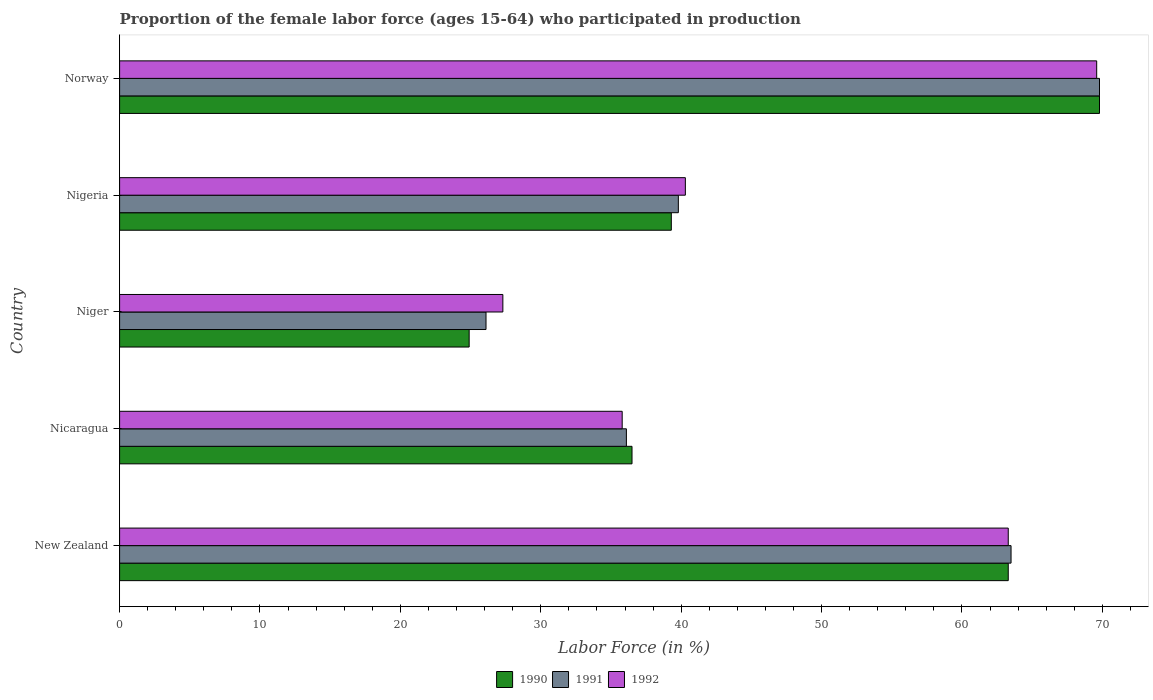How many different coloured bars are there?
Offer a terse response. 3. Are the number of bars per tick equal to the number of legend labels?
Your answer should be compact. Yes. Are the number of bars on each tick of the Y-axis equal?
Your response must be concise. Yes. What is the label of the 5th group of bars from the top?
Keep it short and to the point. New Zealand. In how many cases, is the number of bars for a given country not equal to the number of legend labels?
Your response must be concise. 0. What is the proportion of the female labor force who participated in production in 1992 in New Zealand?
Your answer should be compact. 63.3. Across all countries, what is the maximum proportion of the female labor force who participated in production in 1991?
Give a very brief answer. 69.8. Across all countries, what is the minimum proportion of the female labor force who participated in production in 1992?
Give a very brief answer. 27.3. In which country was the proportion of the female labor force who participated in production in 1990 maximum?
Your answer should be very brief. Norway. In which country was the proportion of the female labor force who participated in production in 1991 minimum?
Offer a terse response. Niger. What is the total proportion of the female labor force who participated in production in 1990 in the graph?
Offer a very short reply. 233.8. What is the difference between the proportion of the female labor force who participated in production in 1990 in New Zealand and that in Niger?
Your answer should be very brief. 38.4. What is the difference between the proportion of the female labor force who participated in production in 1991 in New Zealand and the proportion of the female labor force who participated in production in 1992 in Niger?
Offer a terse response. 36.2. What is the average proportion of the female labor force who participated in production in 1992 per country?
Your answer should be very brief. 47.26. What is the difference between the proportion of the female labor force who participated in production in 1991 and proportion of the female labor force who participated in production in 1992 in New Zealand?
Your answer should be compact. 0.2. What is the ratio of the proportion of the female labor force who participated in production in 1991 in New Zealand to that in Nigeria?
Provide a succinct answer. 1.6. Is the proportion of the female labor force who participated in production in 1991 in Nigeria less than that in Norway?
Make the answer very short. Yes. Is the difference between the proportion of the female labor force who participated in production in 1991 in Nicaragua and Nigeria greater than the difference between the proportion of the female labor force who participated in production in 1992 in Nicaragua and Nigeria?
Make the answer very short. Yes. What is the difference between the highest and the second highest proportion of the female labor force who participated in production in 1992?
Ensure brevity in your answer.  6.3. What is the difference between the highest and the lowest proportion of the female labor force who participated in production in 1992?
Your response must be concise. 42.3. Is the sum of the proportion of the female labor force who participated in production in 1991 in Nigeria and Norway greater than the maximum proportion of the female labor force who participated in production in 1990 across all countries?
Your answer should be very brief. Yes. How many bars are there?
Offer a very short reply. 15. Are the values on the major ticks of X-axis written in scientific E-notation?
Provide a succinct answer. No. Does the graph contain grids?
Offer a very short reply. No. What is the title of the graph?
Keep it short and to the point. Proportion of the female labor force (ages 15-64) who participated in production. What is the label or title of the Y-axis?
Ensure brevity in your answer.  Country. What is the Labor Force (in %) in 1990 in New Zealand?
Your answer should be very brief. 63.3. What is the Labor Force (in %) of 1991 in New Zealand?
Offer a very short reply. 63.5. What is the Labor Force (in %) of 1992 in New Zealand?
Keep it short and to the point. 63.3. What is the Labor Force (in %) of 1990 in Nicaragua?
Your response must be concise. 36.5. What is the Labor Force (in %) in 1991 in Nicaragua?
Make the answer very short. 36.1. What is the Labor Force (in %) of 1992 in Nicaragua?
Give a very brief answer. 35.8. What is the Labor Force (in %) of 1990 in Niger?
Ensure brevity in your answer.  24.9. What is the Labor Force (in %) of 1991 in Niger?
Keep it short and to the point. 26.1. What is the Labor Force (in %) in 1992 in Niger?
Your answer should be compact. 27.3. What is the Labor Force (in %) in 1990 in Nigeria?
Offer a terse response. 39.3. What is the Labor Force (in %) in 1991 in Nigeria?
Keep it short and to the point. 39.8. What is the Labor Force (in %) of 1992 in Nigeria?
Ensure brevity in your answer.  40.3. What is the Labor Force (in %) in 1990 in Norway?
Your answer should be very brief. 69.8. What is the Labor Force (in %) of 1991 in Norway?
Give a very brief answer. 69.8. What is the Labor Force (in %) of 1992 in Norway?
Keep it short and to the point. 69.6. Across all countries, what is the maximum Labor Force (in %) in 1990?
Your answer should be compact. 69.8. Across all countries, what is the maximum Labor Force (in %) in 1991?
Provide a succinct answer. 69.8. Across all countries, what is the maximum Labor Force (in %) of 1992?
Keep it short and to the point. 69.6. Across all countries, what is the minimum Labor Force (in %) of 1990?
Your response must be concise. 24.9. Across all countries, what is the minimum Labor Force (in %) of 1991?
Provide a succinct answer. 26.1. Across all countries, what is the minimum Labor Force (in %) of 1992?
Provide a short and direct response. 27.3. What is the total Labor Force (in %) in 1990 in the graph?
Your answer should be compact. 233.8. What is the total Labor Force (in %) in 1991 in the graph?
Your answer should be compact. 235.3. What is the total Labor Force (in %) of 1992 in the graph?
Provide a succinct answer. 236.3. What is the difference between the Labor Force (in %) in 1990 in New Zealand and that in Nicaragua?
Keep it short and to the point. 26.8. What is the difference between the Labor Force (in %) of 1991 in New Zealand and that in Nicaragua?
Offer a very short reply. 27.4. What is the difference between the Labor Force (in %) in 1990 in New Zealand and that in Niger?
Your answer should be compact. 38.4. What is the difference between the Labor Force (in %) of 1991 in New Zealand and that in Niger?
Offer a very short reply. 37.4. What is the difference between the Labor Force (in %) in 1992 in New Zealand and that in Niger?
Provide a succinct answer. 36. What is the difference between the Labor Force (in %) in 1990 in New Zealand and that in Nigeria?
Ensure brevity in your answer.  24. What is the difference between the Labor Force (in %) in 1991 in New Zealand and that in Nigeria?
Offer a terse response. 23.7. What is the difference between the Labor Force (in %) of 1992 in New Zealand and that in Nigeria?
Offer a terse response. 23. What is the difference between the Labor Force (in %) in 1990 in New Zealand and that in Norway?
Provide a succinct answer. -6.5. What is the difference between the Labor Force (in %) of 1992 in New Zealand and that in Norway?
Ensure brevity in your answer.  -6.3. What is the difference between the Labor Force (in %) in 1990 in Nicaragua and that in Niger?
Provide a short and direct response. 11.6. What is the difference between the Labor Force (in %) in 1992 in Nicaragua and that in Niger?
Provide a short and direct response. 8.5. What is the difference between the Labor Force (in %) in 1990 in Nicaragua and that in Nigeria?
Keep it short and to the point. -2.8. What is the difference between the Labor Force (in %) in 1990 in Nicaragua and that in Norway?
Make the answer very short. -33.3. What is the difference between the Labor Force (in %) in 1991 in Nicaragua and that in Norway?
Give a very brief answer. -33.7. What is the difference between the Labor Force (in %) of 1992 in Nicaragua and that in Norway?
Ensure brevity in your answer.  -33.8. What is the difference between the Labor Force (in %) of 1990 in Niger and that in Nigeria?
Give a very brief answer. -14.4. What is the difference between the Labor Force (in %) of 1991 in Niger and that in Nigeria?
Your answer should be compact. -13.7. What is the difference between the Labor Force (in %) of 1992 in Niger and that in Nigeria?
Your answer should be compact. -13. What is the difference between the Labor Force (in %) of 1990 in Niger and that in Norway?
Ensure brevity in your answer.  -44.9. What is the difference between the Labor Force (in %) of 1991 in Niger and that in Norway?
Give a very brief answer. -43.7. What is the difference between the Labor Force (in %) in 1992 in Niger and that in Norway?
Your response must be concise. -42.3. What is the difference between the Labor Force (in %) of 1990 in Nigeria and that in Norway?
Keep it short and to the point. -30.5. What is the difference between the Labor Force (in %) of 1991 in Nigeria and that in Norway?
Provide a succinct answer. -30. What is the difference between the Labor Force (in %) of 1992 in Nigeria and that in Norway?
Your answer should be very brief. -29.3. What is the difference between the Labor Force (in %) of 1990 in New Zealand and the Labor Force (in %) of 1991 in Nicaragua?
Provide a succinct answer. 27.2. What is the difference between the Labor Force (in %) of 1990 in New Zealand and the Labor Force (in %) of 1992 in Nicaragua?
Make the answer very short. 27.5. What is the difference between the Labor Force (in %) of 1991 in New Zealand and the Labor Force (in %) of 1992 in Nicaragua?
Your answer should be very brief. 27.7. What is the difference between the Labor Force (in %) of 1990 in New Zealand and the Labor Force (in %) of 1991 in Niger?
Your response must be concise. 37.2. What is the difference between the Labor Force (in %) in 1991 in New Zealand and the Labor Force (in %) in 1992 in Niger?
Offer a very short reply. 36.2. What is the difference between the Labor Force (in %) in 1990 in New Zealand and the Labor Force (in %) in 1991 in Nigeria?
Offer a terse response. 23.5. What is the difference between the Labor Force (in %) in 1991 in New Zealand and the Labor Force (in %) in 1992 in Nigeria?
Provide a succinct answer. 23.2. What is the difference between the Labor Force (in %) of 1990 in New Zealand and the Labor Force (in %) of 1992 in Norway?
Make the answer very short. -6.3. What is the difference between the Labor Force (in %) of 1990 in Nicaragua and the Labor Force (in %) of 1992 in Niger?
Keep it short and to the point. 9.2. What is the difference between the Labor Force (in %) in 1990 in Nicaragua and the Labor Force (in %) in 1991 in Nigeria?
Your response must be concise. -3.3. What is the difference between the Labor Force (in %) in 1990 in Nicaragua and the Labor Force (in %) in 1992 in Nigeria?
Keep it short and to the point. -3.8. What is the difference between the Labor Force (in %) of 1991 in Nicaragua and the Labor Force (in %) of 1992 in Nigeria?
Give a very brief answer. -4.2. What is the difference between the Labor Force (in %) in 1990 in Nicaragua and the Labor Force (in %) in 1991 in Norway?
Keep it short and to the point. -33.3. What is the difference between the Labor Force (in %) of 1990 in Nicaragua and the Labor Force (in %) of 1992 in Norway?
Offer a terse response. -33.1. What is the difference between the Labor Force (in %) of 1991 in Nicaragua and the Labor Force (in %) of 1992 in Norway?
Your answer should be very brief. -33.5. What is the difference between the Labor Force (in %) in 1990 in Niger and the Labor Force (in %) in 1991 in Nigeria?
Give a very brief answer. -14.9. What is the difference between the Labor Force (in %) in 1990 in Niger and the Labor Force (in %) in 1992 in Nigeria?
Offer a terse response. -15.4. What is the difference between the Labor Force (in %) in 1991 in Niger and the Labor Force (in %) in 1992 in Nigeria?
Make the answer very short. -14.2. What is the difference between the Labor Force (in %) of 1990 in Niger and the Labor Force (in %) of 1991 in Norway?
Keep it short and to the point. -44.9. What is the difference between the Labor Force (in %) of 1990 in Niger and the Labor Force (in %) of 1992 in Norway?
Provide a succinct answer. -44.7. What is the difference between the Labor Force (in %) of 1991 in Niger and the Labor Force (in %) of 1992 in Norway?
Offer a terse response. -43.5. What is the difference between the Labor Force (in %) of 1990 in Nigeria and the Labor Force (in %) of 1991 in Norway?
Keep it short and to the point. -30.5. What is the difference between the Labor Force (in %) of 1990 in Nigeria and the Labor Force (in %) of 1992 in Norway?
Your answer should be very brief. -30.3. What is the difference between the Labor Force (in %) of 1991 in Nigeria and the Labor Force (in %) of 1992 in Norway?
Offer a very short reply. -29.8. What is the average Labor Force (in %) in 1990 per country?
Your answer should be very brief. 46.76. What is the average Labor Force (in %) of 1991 per country?
Your answer should be compact. 47.06. What is the average Labor Force (in %) of 1992 per country?
Your answer should be compact. 47.26. What is the difference between the Labor Force (in %) of 1990 and Labor Force (in %) of 1991 in New Zealand?
Ensure brevity in your answer.  -0.2. What is the difference between the Labor Force (in %) of 1990 and Labor Force (in %) of 1992 in New Zealand?
Your answer should be very brief. 0. What is the difference between the Labor Force (in %) in 1991 and Labor Force (in %) in 1992 in New Zealand?
Your answer should be compact. 0.2. What is the difference between the Labor Force (in %) of 1990 and Labor Force (in %) of 1991 in Nicaragua?
Ensure brevity in your answer.  0.4. What is the difference between the Labor Force (in %) in 1990 and Labor Force (in %) in 1992 in Nicaragua?
Provide a short and direct response. 0.7. What is the difference between the Labor Force (in %) of 1990 and Labor Force (in %) of 1991 in Niger?
Your answer should be compact. -1.2. What is the difference between the Labor Force (in %) in 1990 and Labor Force (in %) in 1991 in Nigeria?
Your answer should be compact. -0.5. What is the difference between the Labor Force (in %) in 1990 and Labor Force (in %) in 1992 in Nigeria?
Keep it short and to the point. -1. What is the difference between the Labor Force (in %) of 1991 and Labor Force (in %) of 1992 in Nigeria?
Provide a succinct answer. -0.5. What is the difference between the Labor Force (in %) of 1990 and Labor Force (in %) of 1992 in Norway?
Ensure brevity in your answer.  0.2. What is the difference between the Labor Force (in %) in 1991 and Labor Force (in %) in 1992 in Norway?
Keep it short and to the point. 0.2. What is the ratio of the Labor Force (in %) of 1990 in New Zealand to that in Nicaragua?
Give a very brief answer. 1.73. What is the ratio of the Labor Force (in %) of 1991 in New Zealand to that in Nicaragua?
Offer a very short reply. 1.76. What is the ratio of the Labor Force (in %) in 1992 in New Zealand to that in Nicaragua?
Keep it short and to the point. 1.77. What is the ratio of the Labor Force (in %) in 1990 in New Zealand to that in Niger?
Provide a succinct answer. 2.54. What is the ratio of the Labor Force (in %) in 1991 in New Zealand to that in Niger?
Your answer should be compact. 2.43. What is the ratio of the Labor Force (in %) in 1992 in New Zealand to that in Niger?
Your answer should be very brief. 2.32. What is the ratio of the Labor Force (in %) of 1990 in New Zealand to that in Nigeria?
Offer a terse response. 1.61. What is the ratio of the Labor Force (in %) in 1991 in New Zealand to that in Nigeria?
Your answer should be compact. 1.6. What is the ratio of the Labor Force (in %) of 1992 in New Zealand to that in Nigeria?
Provide a short and direct response. 1.57. What is the ratio of the Labor Force (in %) in 1990 in New Zealand to that in Norway?
Ensure brevity in your answer.  0.91. What is the ratio of the Labor Force (in %) of 1991 in New Zealand to that in Norway?
Offer a very short reply. 0.91. What is the ratio of the Labor Force (in %) in 1992 in New Zealand to that in Norway?
Your answer should be very brief. 0.91. What is the ratio of the Labor Force (in %) in 1990 in Nicaragua to that in Niger?
Make the answer very short. 1.47. What is the ratio of the Labor Force (in %) in 1991 in Nicaragua to that in Niger?
Offer a terse response. 1.38. What is the ratio of the Labor Force (in %) of 1992 in Nicaragua to that in Niger?
Your answer should be compact. 1.31. What is the ratio of the Labor Force (in %) of 1990 in Nicaragua to that in Nigeria?
Your answer should be compact. 0.93. What is the ratio of the Labor Force (in %) in 1991 in Nicaragua to that in Nigeria?
Ensure brevity in your answer.  0.91. What is the ratio of the Labor Force (in %) of 1992 in Nicaragua to that in Nigeria?
Your answer should be very brief. 0.89. What is the ratio of the Labor Force (in %) in 1990 in Nicaragua to that in Norway?
Keep it short and to the point. 0.52. What is the ratio of the Labor Force (in %) of 1991 in Nicaragua to that in Norway?
Offer a very short reply. 0.52. What is the ratio of the Labor Force (in %) in 1992 in Nicaragua to that in Norway?
Keep it short and to the point. 0.51. What is the ratio of the Labor Force (in %) of 1990 in Niger to that in Nigeria?
Offer a terse response. 0.63. What is the ratio of the Labor Force (in %) in 1991 in Niger to that in Nigeria?
Offer a terse response. 0.66. What is the ratio of the Labor Force (in %) in 1992 in Niger to that in Nigeria?
Give a very brief answer. 0.68. What is the ratio of the Labor Force (in %) of 1990 in Niger to that in Norway?
Provide a succinct answer. 0.36. What is the ratio of the Labor Force (in %) of 1991 in Niger to that in Norway?
Provide a short and direct response. 0.37. What is the ratio of the Labor Force (in %) in 1992 in Niger to that in Norway?
Your answer should be compact. 0.39. What is the ratio of the Labor Force (in %) of 1990 in Nigeria to that in Norway?
Provide a succinct answer. 0.56. What is the ratio of the Labor Force (in %) of 1991 in Nigeria to that in Norway?
Offer a very short reply. 0.57. What is the ratio of the Labor Force (in %) in 1992 in Nigeria to that in Norway?
Keep it short and to the point. 0.58. What is the difference between the highest and the second highest Labor Force (in %) in 1991?
Provide a short and direct response. 6.3. What is the difference between the highest and the lowest Labor Force (in %) in 1990?
Your response must be concise. 44.9. What is the difference between the highest and the lowest Labor Force (in %) in 1991?
Offer a very short reply. 43.7. What is the difference between the highest and the lowest Labor Force (in %) in 1992?
Offer a terse response. 42.3. 